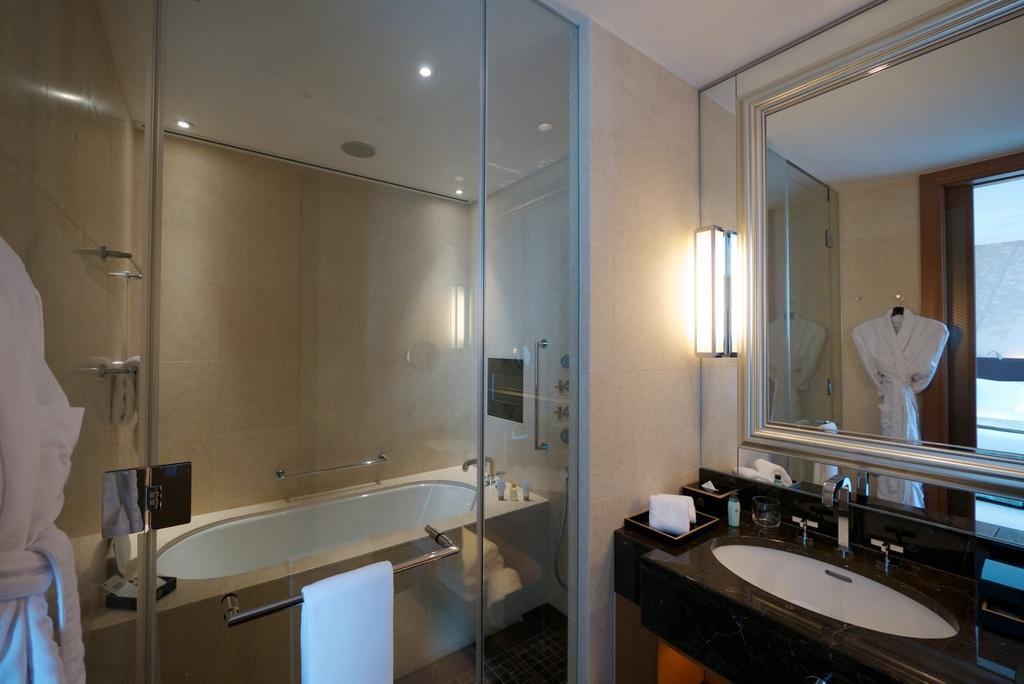What is the main object in the image? There is a bathtub in the image. What is attached to the bathtub? A towel bar is fixed to the bathtub. What can be seen on the right side of the image? There is a mirror and a sink on the right side of the image. What is visible in the background of the image? There is a wall visible in the background of the image. What type of grass is growing on the wall in the image? There is no grass present in the image; it features a bathtub, towel bar, mirror, sink, and a wall. What alarm is going off in the image? There is no alarm present in the image. 